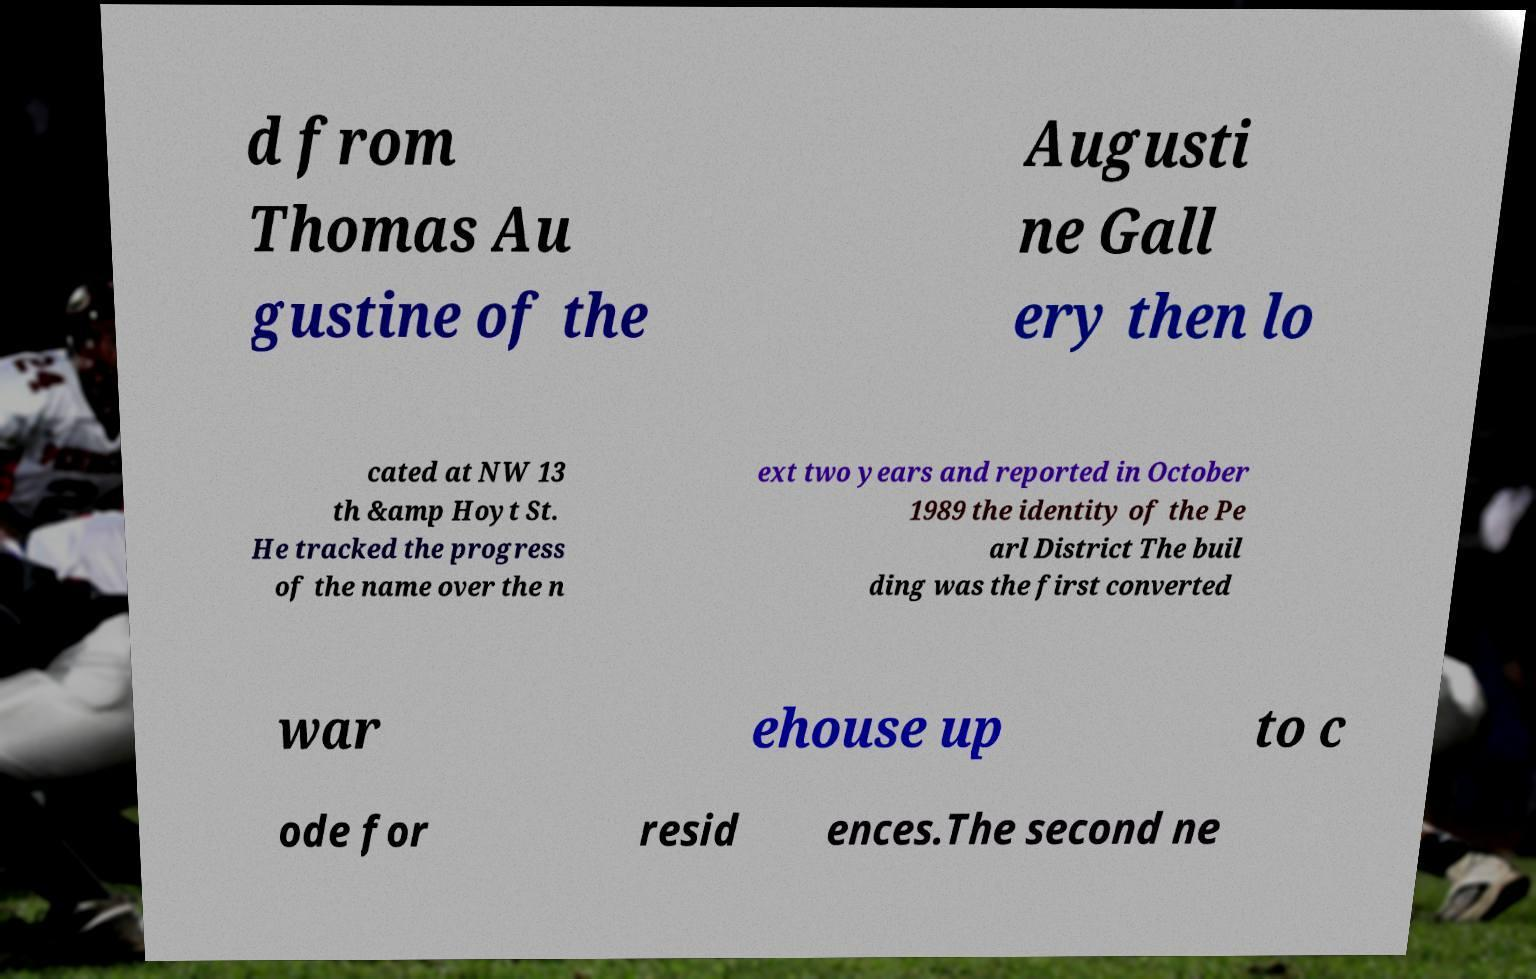Could you extract and type out the text from this image? d from Thomas Au gustine of the Augusti ne Gall ery then lo cated at NW 13 th &amp Hoyt St. He tracked the progress of the name over the n ext two years and reported in October 1989 the identity of the Pe arl District The buil ding was the first converted war ehouse up to c ode for resid ences.The second ne 